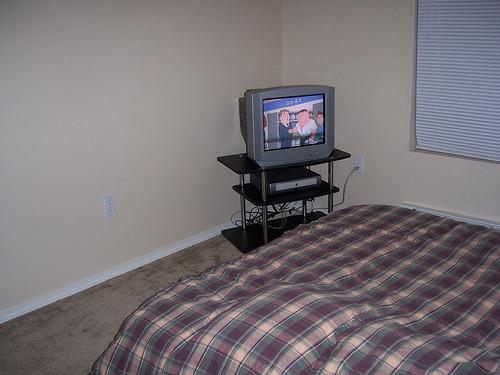What show is on the TV?
Answer briefly. Family guy. What is the pattern on the bedspread?
Short answer required. Plaid. Is this bedroom sparsely furnished?
Be succinct. Yes. 